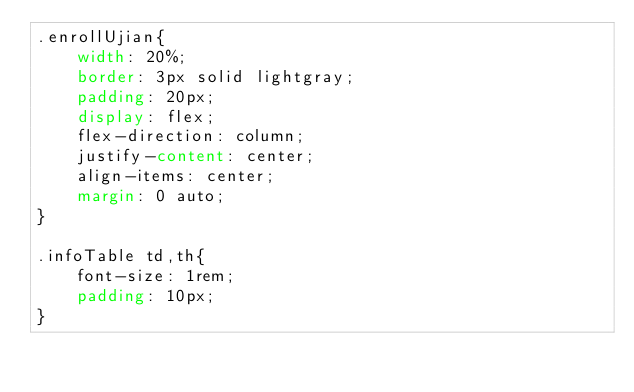Convert code to text. <code><loc_0><loc_0><loc_500><loc_500><_CSS_>.enrollUjian{
    width: 20%;
    border: 3px solid lightgray;
    padding: 20px;
    display: flex;
    flex-direction: column;
    justify-content: center;
    align-items: center;
    margin: 0 auto;
}

.infoTable td,th{
    font-size: 1rem;
    padding: 10px;
}
</code> 